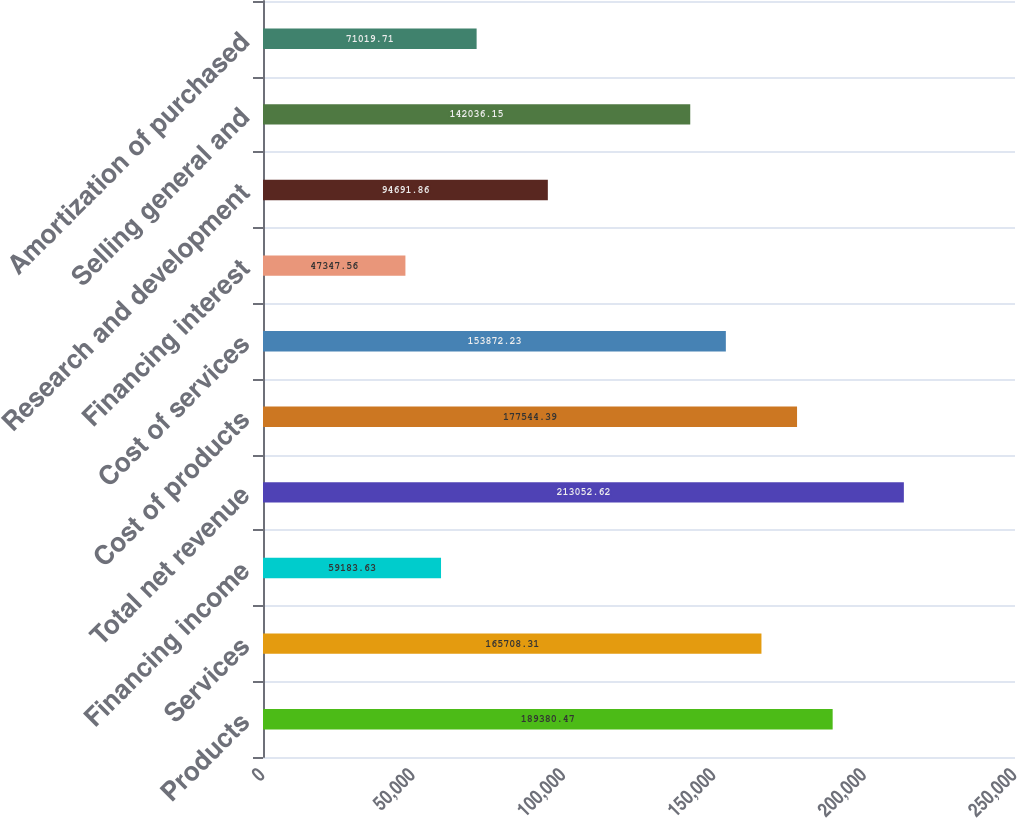Convert chart to OTSL. <chart><loc_0><loc_0><loc_500><loc_500><bar_chart><fcel>Products<fcel>Services<fcel>Financing income<fcel>Total net revenue<fcel>Cost of products<fcel>Cost of services<fcel>Financing interest<fcel>Research and development<fcel>Selling general and<fcel>Amortization of purchased<nl><fcel>189380<fcel>165708<fcel>59183.6<fcel>213053<fcel>177544<fcel>153872<fcel>47347.6<fcel>94691.9<fcel>142036<fcel>71019.7<nl></chart> 